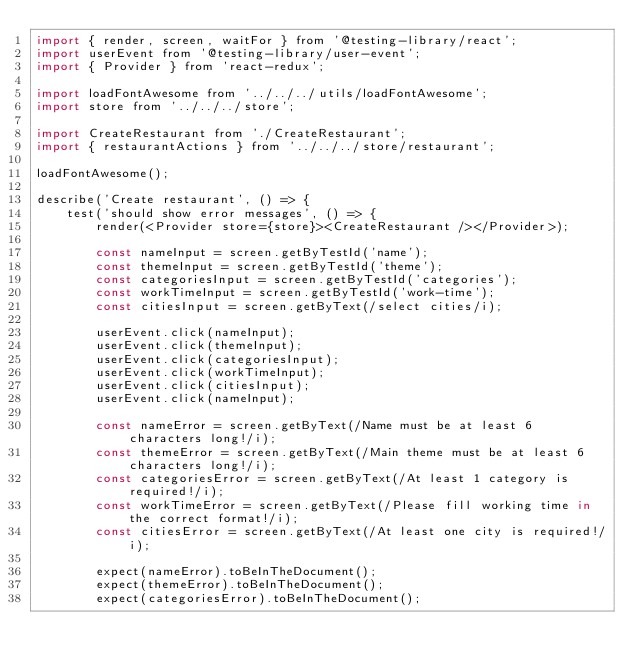<code> <loc_0><loc_0><loc_500><loc_500><_JavaScript_>import { render, screen, waitFor } from '@testing-library/react';
import userEvent from '@testing-library/user-event';
import { Provider } from 'react-redux';

import loadFontAwesome from '../../../utils/loadFontAwesome';
import store from '../../../store';

import CreateRestaurant from './CreateRestaurant';
import { restaurantActions } from '../../../store/restaurant';

loadFontAwesome();

describe('Create restaurant', () => {
    test('should show error messages', () => {
        render(<Provider store={store}><CreateRestaurant /></Provider>);

        const nameInput = screen.getByTestId('name');
        const themeInput = screen.getByTestId('theme');
        const categoriesInput = screen.getByTestId('categories');
        const workTimeInput = screen.getByTestId('work-time');
        const citiesInput = screen.getByText(/select cities/i);

        userEvent.click(nameInput);
        userEvent.click(themeInput);
        userEvent.click(categoriesInput);
        userEvent.click(workTimeInput);
        userEvent.click(citiesInput);
        userEvent.click(nameInput);

        const nameError = screen.getByText(/Name must be at least 6 characters long!/i);
        const themeError = screen.getByText(/Main theme must be at least 6 characters long!/i);
        const categoriesError = screen.getByText(/At least 1 category is required!/i);
        const workTimeError = screen.getByText(/Please fill working time in the correct format!/i);
        const citiesError = screen.getByText(/At least one city is required!/i);

        expect(nameError).toBeInTheDocument();
        expect(themeError).toBeInTheDocument();
        expect(categoriesError).toBeInTheDocument();</code> 